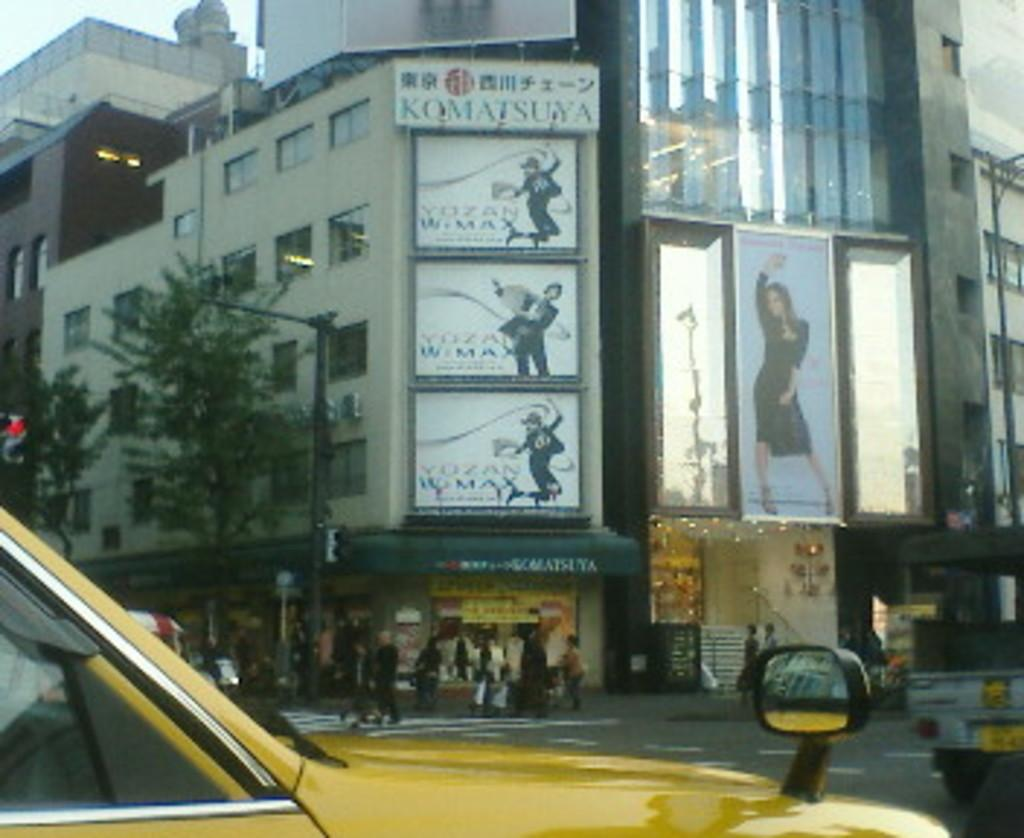<image>
Create a compact narrative representing the image presented. A large billboard for Komatsuya shows three panels of photographs. 